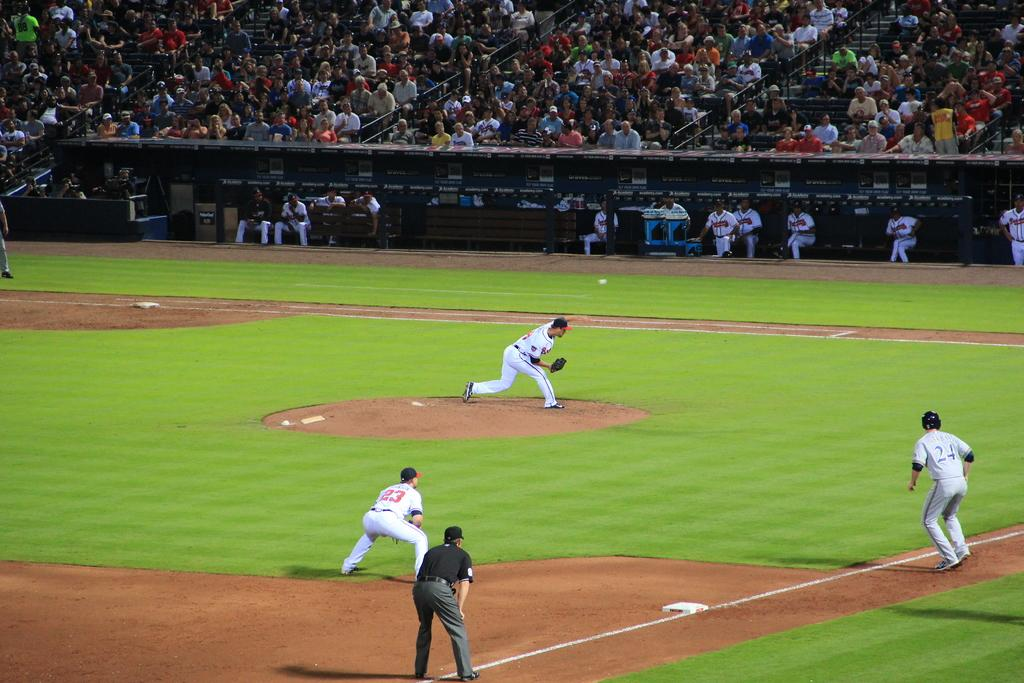<image>
Write a terse but informative summary of the picture. Player number 23 crouches as he watches where the ball is going. 